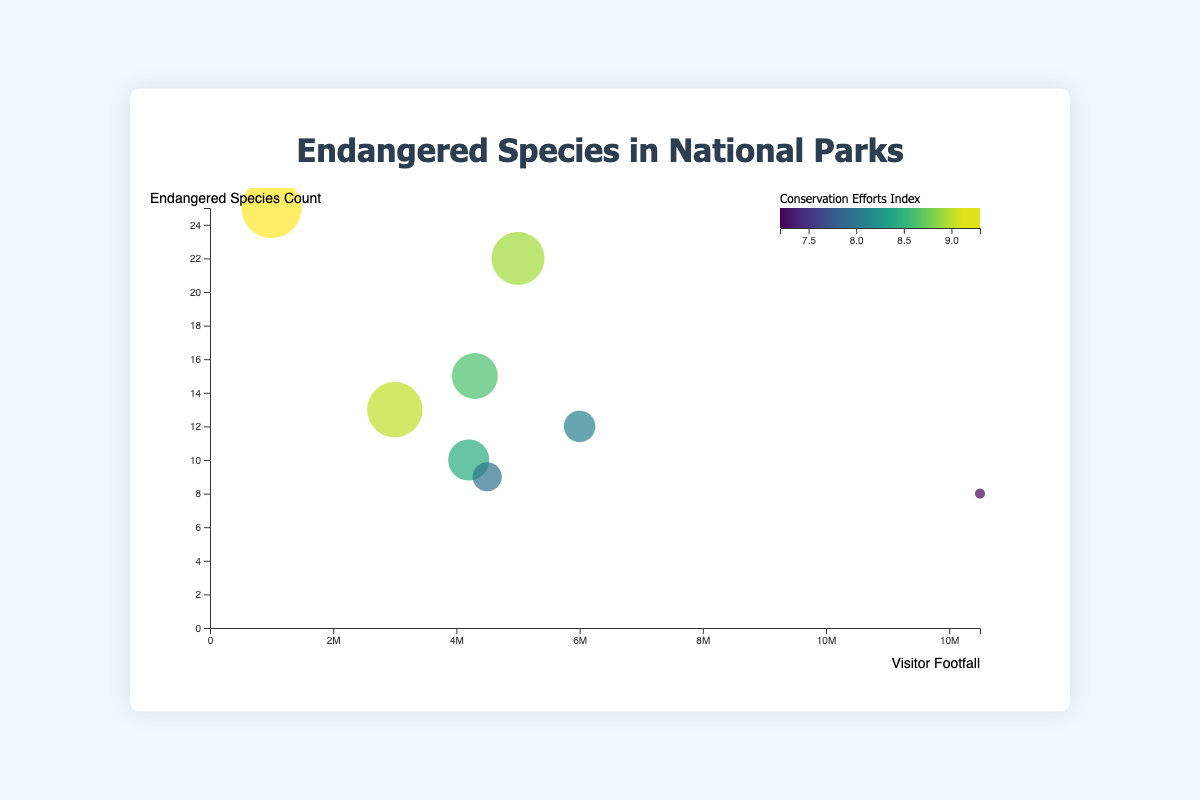What is the title of the figure? The title of the figure is usually displayed prominently at the top center. It reads "Endangered Species in National Parks."
Answer: Endangered Species in National Parks How many national parks are depicted in the figure? By counting the number of data points (bubbles) in the plot, you can see that there are 8 bubbles, each representing a national park.
Answer: 8 Which national park has the highest number of endangered species? By checking the Y-axis (Endangered Species Count), Everglades National Park has the highest position along this axis, indicating the highest number of endangered species.
Answer: Everglades National Park Which national park has the highest visitor footfall? By looking at the X-axis (Visitor Footfall), Great Smoky Mountains National Park is the farthest to the right, indicating it has the highest visitor numbers.
Answer: Great Smoky Mountains National Park What is the conservation efforts index of Zion National Park? By hovering over or checking the bubble for Zion National Park, the tooltip or visual cue will show that its conservation efforts index is 8.7.
Answer: 8.7 What is the average endangered species count across all the national parks? We add up the endangered species counts for all 8 parks (10 + 22 + 8 + 25 + 12 + 15 + 9 + 13) to get 114 and then divide by 8.
Answer: 14.25 Which national park has the smallest bubble size and what does that indicate? The smallest bubble indicates the lowest conservation efforts index. By looking at the smallest bubble, Grand Canyon National Park has this characteristic.
Answer: Grand Canyon National Park Which park has a higher conservation efforts index, Glacier National Park or Yellowstone National Park? By comparing the bubble sizes and the color gradients for Glacier and Yellowstone, Glacier has a higher index of 9.1 compared to Yellowstone's 8.5.
Answer: Glacier National Park Is there any correlation between visitor footfall and conservation efforts index? By observing the sizes and positions of the bubbles on both axes, there is no clear correlation where higher visitor footfall consistently corresponds to higher conservation efforts or vice versa. The data points are scattered across the plot.
Answer: No clear correlation 